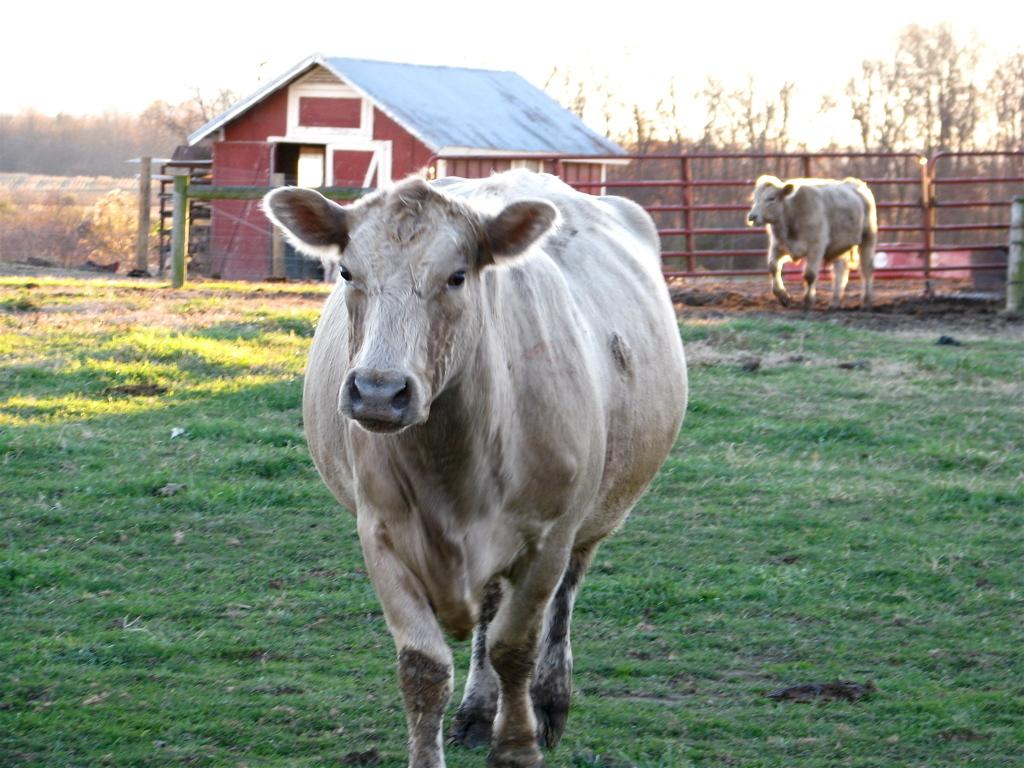How many cows are in the image? There are two cows in the image. What type of vegetation is at the bottom of the image? There is green grass at the bottom of the image. What can be seen in the background of the image? There is a fence, a house, and many plants and trees in the background of the image. Where is the faucet located in the image? There is no faucet present in the image. What type of transport is the man using in the image? There is no man present in the image, and therefore no transport can be observed. 